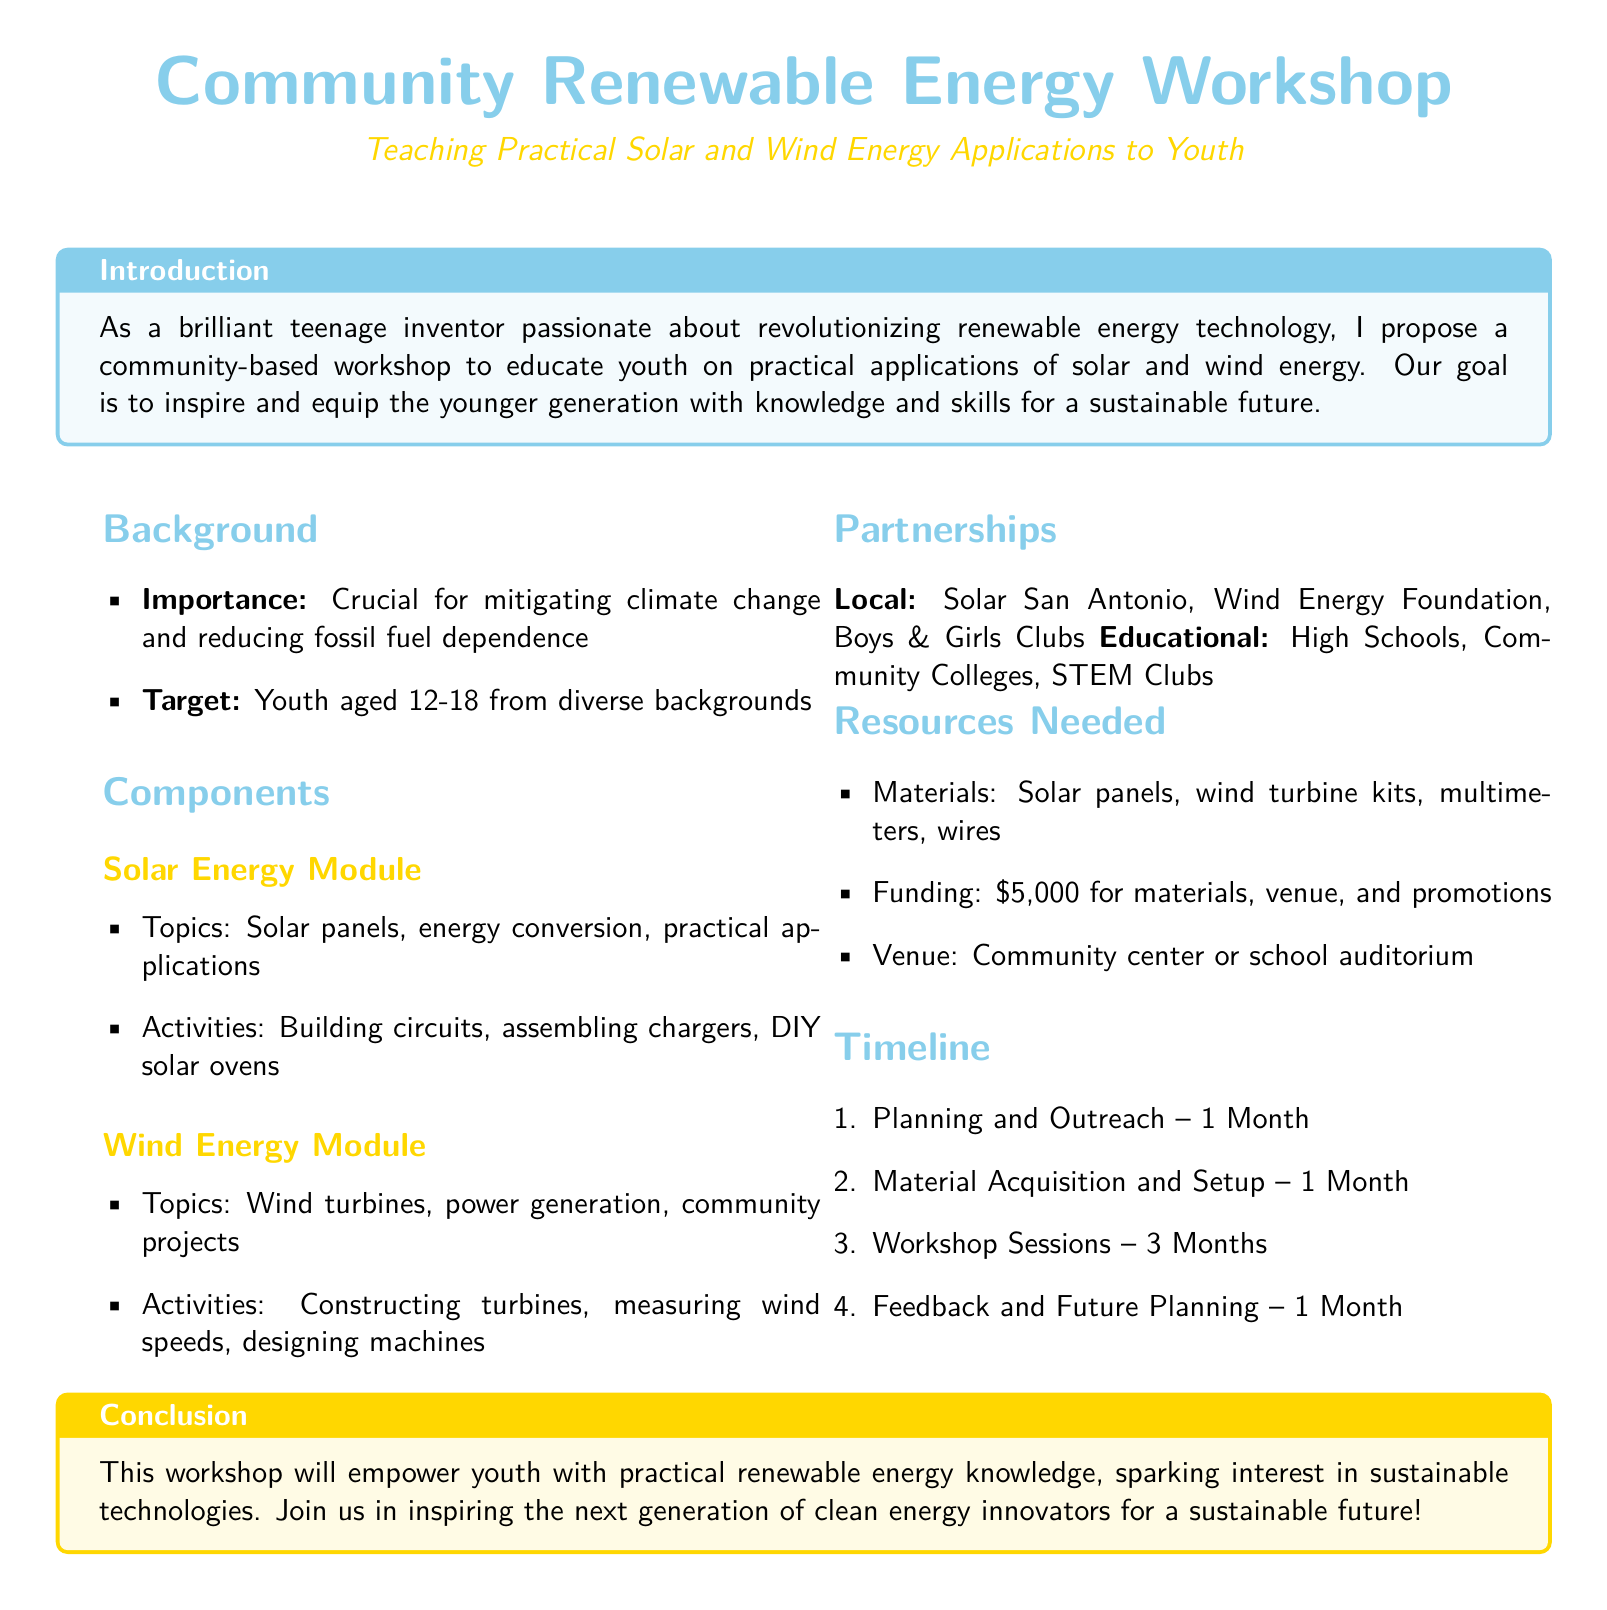What is the workshop's target audience? The document states that the target audience is youth aged 12-18.
Answer: youth aged 12-18 How much funding is needed for the workshop? The document specifies a funding requirement of $5,000 for materials, venue, and promotions.
Answer: $5,000 What is the first step in the timeline? The document outlines that the first step is Planning and Outreach, which takes 1 month.
Answer: Planning and Outreach Which local partnerships are mentioned? The document lists Solar San Antonio, Wind Energy Foundation, and Boys & Girls Clubs as local partners.
Answer: Solar San Antonio, Wind Energy Foundation, Boys & Girls Clubs What activity is part of the Solar Energy Module? The document mentions building circuits as one of the activities in the Solar Energy Module.
Answer: building circuits How long is the workshop session planned to last? The timeline indicates that the workshop sessions will last for 3 months.
Answer: 3 months What is the purpose of the workshop? The document states that the purpose is to educate youth on practical applications of solar and wind energy.
Answer: educate youth on practical applications of solar and wind energy What is the venue type suggested for the workshop? The document suggests a community center or school auditorium as potential venues for the workshop.
Answer: community center or school auditorium 